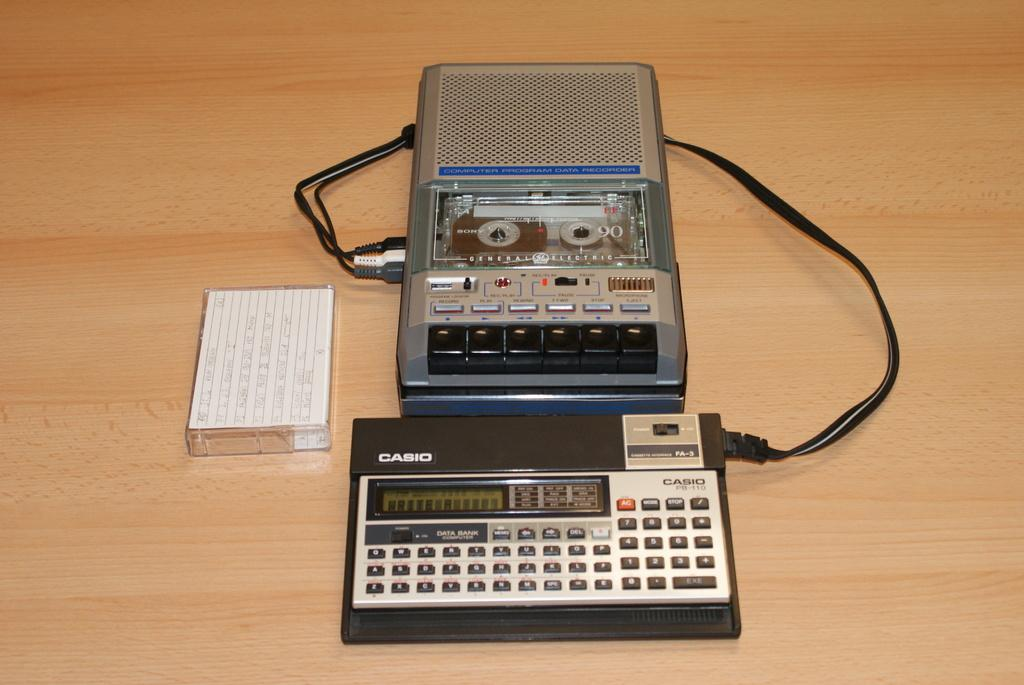<image>
Describe the image concisely. a Casio sitting in front of a tape recorder 